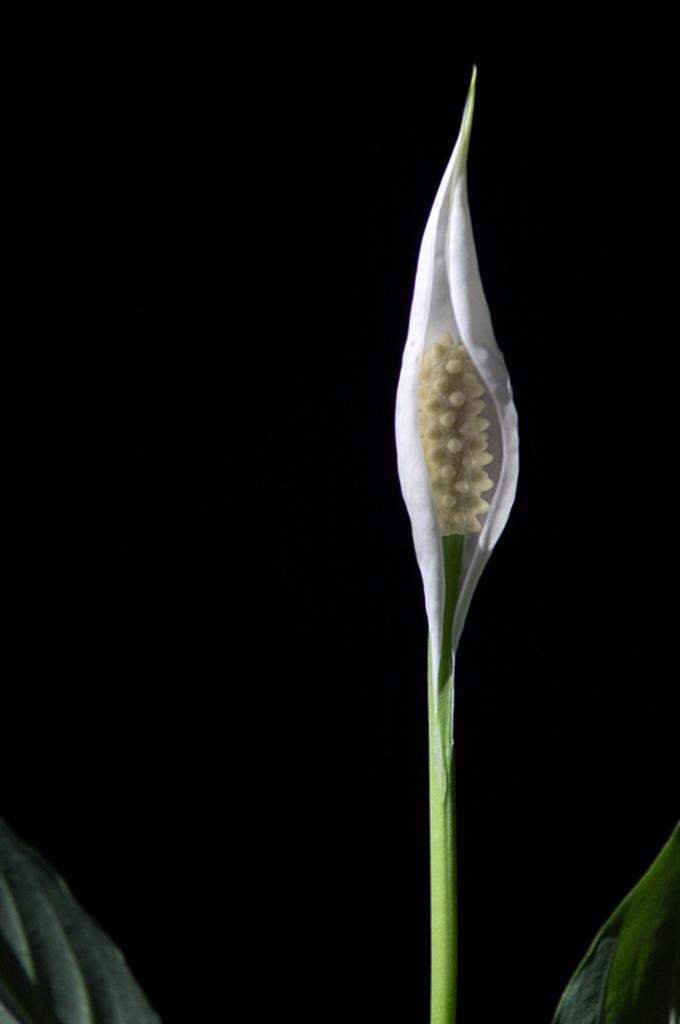What is the main subject of the image? There is a flower in the image. Can you describe the color of the flower? The flower has cream and white colors. What else is visible in the image besides the flower? There are green leaves associated with the flower. What color is the background of the image? The background of the image is black. What type of art can be seen in the background of the image? There is no art visible in the background of the image; it is black. Can you see any ghosts interacting with the flower in the image? There are no ghosts present in the image; it features a flower with green leaves and a black background. 